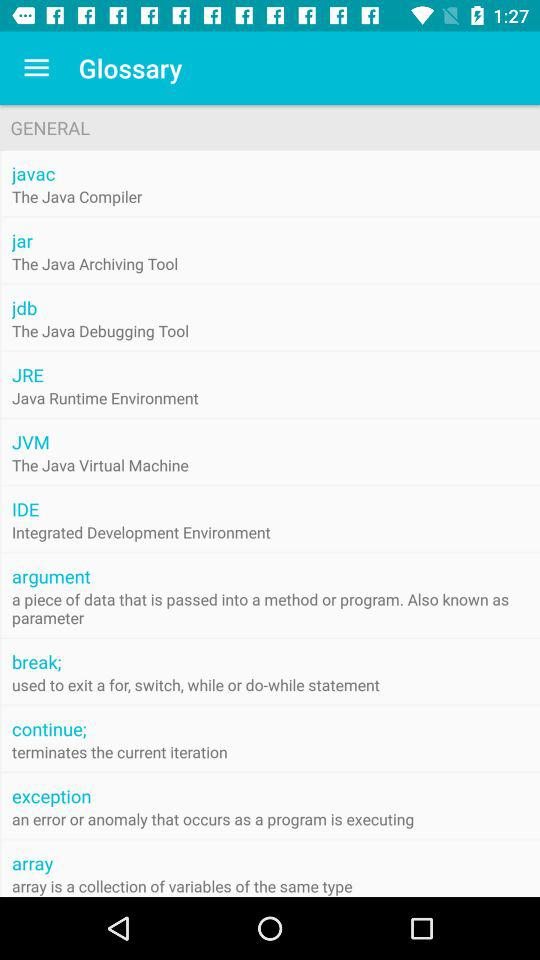What is an IDE? An IDE is an "Integrated Development Environment". 